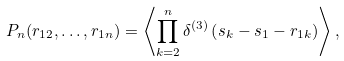<formula> <loc_0><loc_0><loc_500><loc_500>P _ { n } ( { r } _ { 1 2 } , \dots , { r } _ { 1 n } ) = \left \langle \prod _ { k = 2 } ^ { n } \delta ^ { ( 3 ) } \left ( { s } _ { k } - { s } _ { 1 } - { r } _ { 1 k } \right ) \right \rangle ,</formula> 